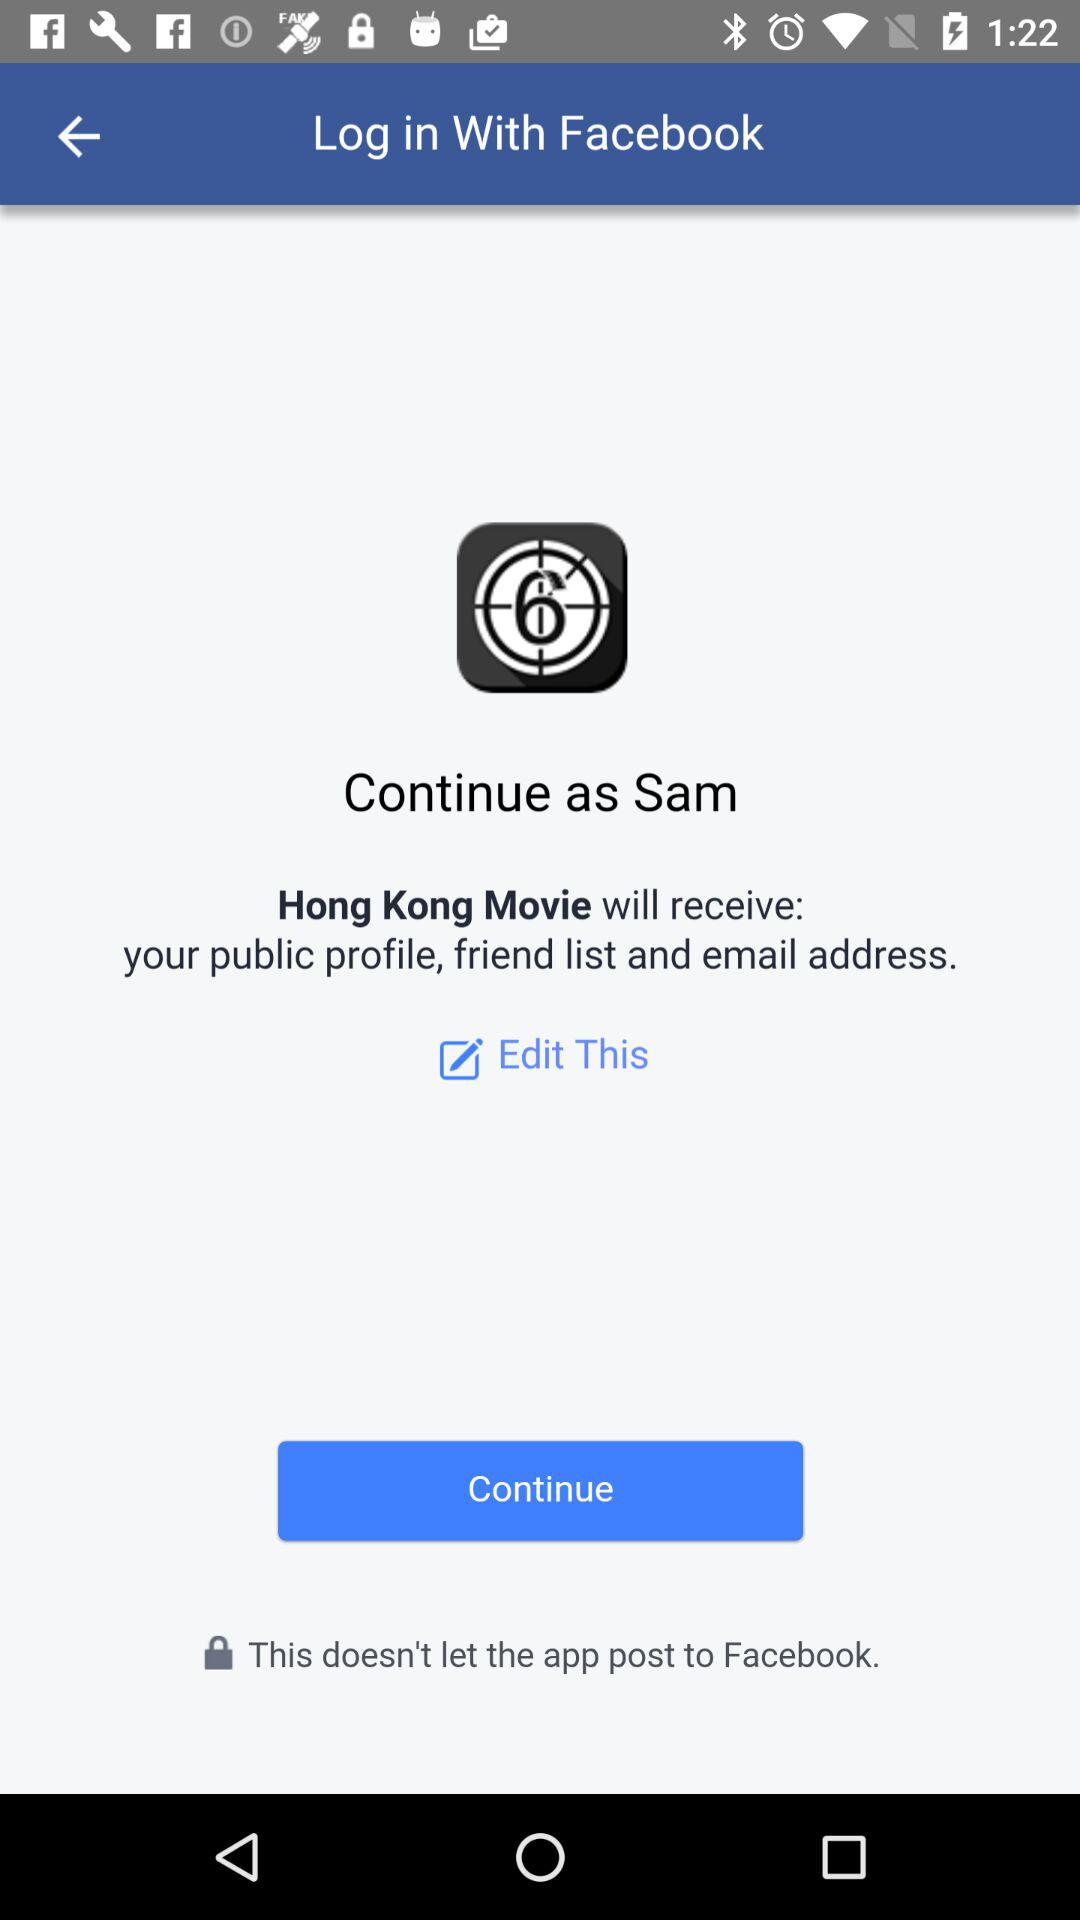What application is asking for permission? The application asking for permission is "Hong Kong Movie". 